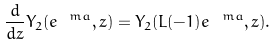Convert formula to latex. <formula><loc_0><loc_0><loc_500><loc_500>\frac { d } { d z } Y _ { 2 } ( e ^ { \ m a } , z ) = Y _ { 2 } ( L ( - 1 ) e ^ { \ m a } , z ) .</formula> 